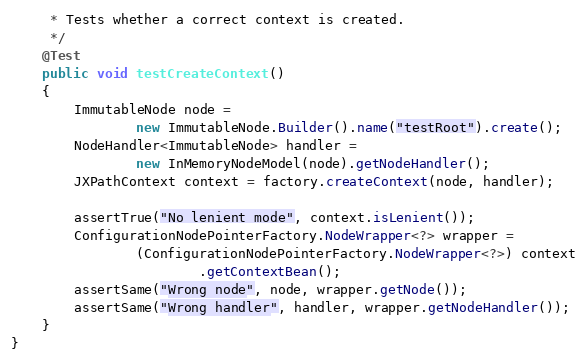Convert code to text. <code><loc_0><loc_0><loc_500><loc_500><_Java_>     * Tests whether a correct context is created.
     */
    @Test
    public void testCreateContext()
    {
        ImmutableNode node =
                new ImmutableNode.Builder().name("testRoot").create();
        NodeHandler<ImmutableNode> handler =
                new InMemoryNodeModel(node).getNodeHandler();
        JXPathContext context = factory.createContext(node, handler);

        assertTrue("No lenient mode", context.isLenient());
        ConfigurationNodePointerFactory.NodeWrapper<?> wrapper =
                (ConfigurationNodePointerFactory.NodeWrapper<?>) context
                        .getContextBean();
        assertSame("Wrong node", node, wrapper.getNode());
        assertSame("Wrong handler", handler, wrapper.getNodeHandler());
    }
}
</code> 